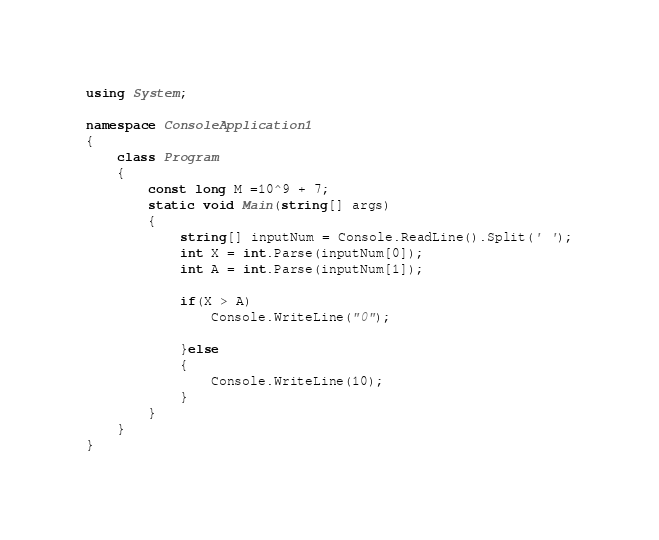Convert code to text. <code><loc_0><loc_0><loc_500><loc_500><_C#_>using System;

namespace ConsoleApplication1
{
    class Program
    {
        const long M =10^9 + 7;
        static void Main(string[] args)
        {
            string[] inputNum = Console.ReadLine().Split(' ');
            int X = int.Parse(inputNum[0]);
            int A = int.Parse(inputNum[1]);

            if(X > A)
                Console.WriteLine("0");

            }else
            {
                Console.WriteLine(10);
            }
        }
    }
}
</code> 